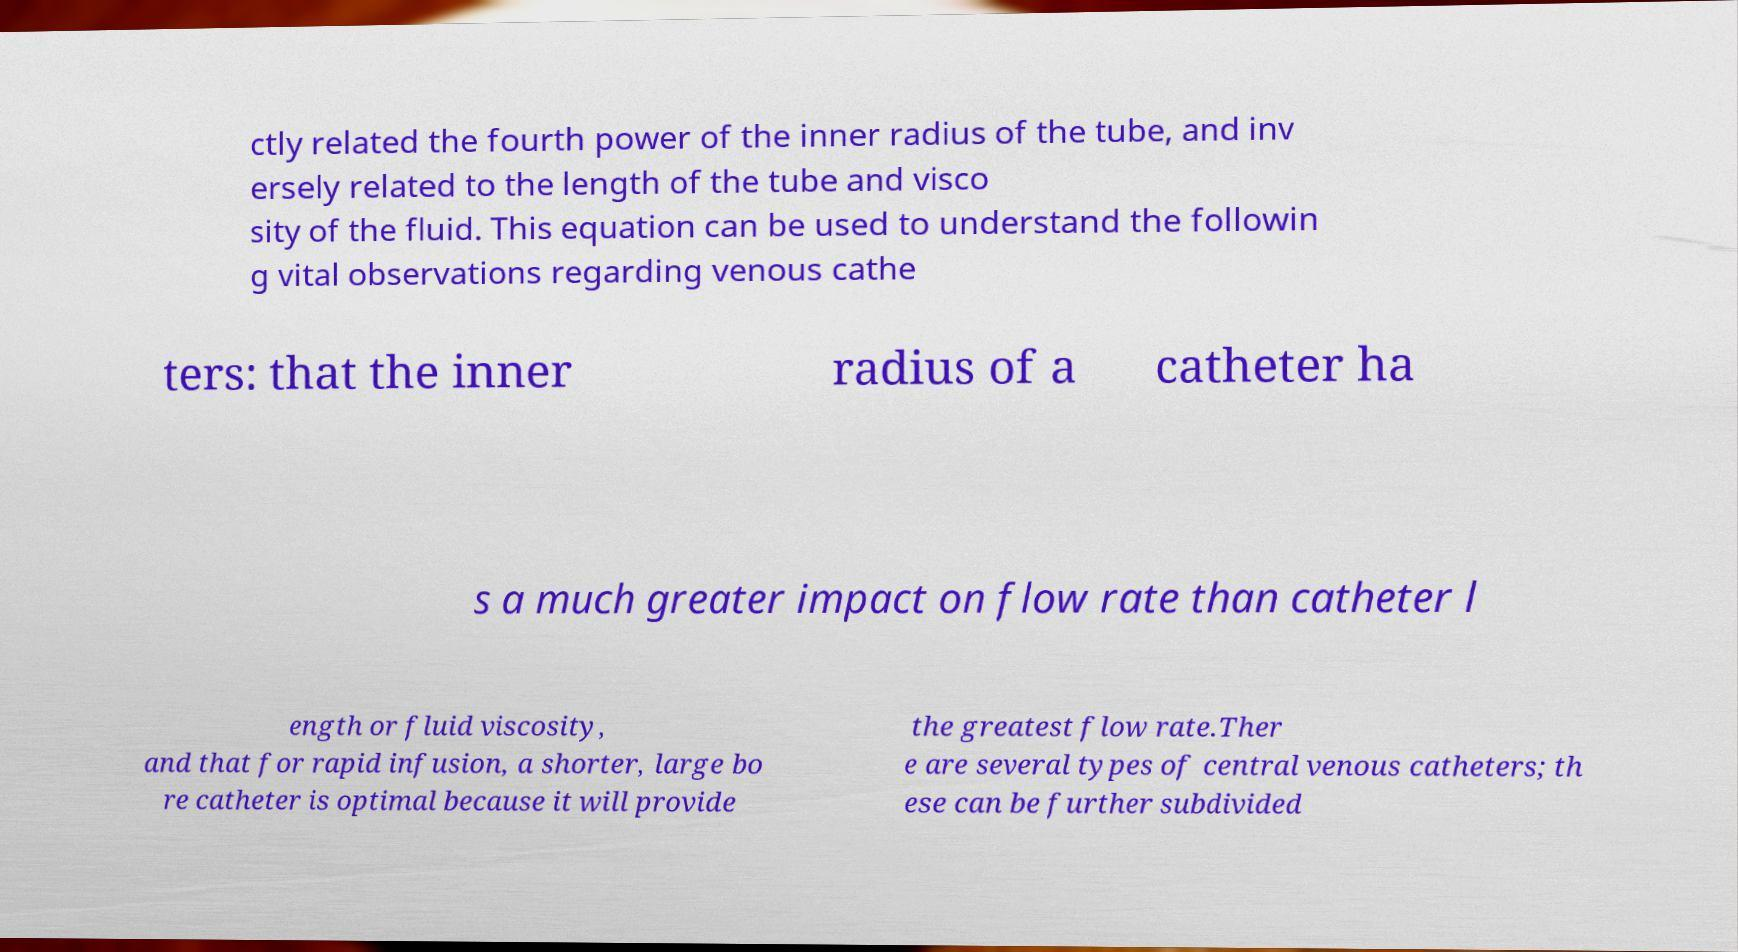For documentation purposes, I need the text within this image transcribed. Could you provide that? ctly related the fourth power of the inner radius of the tube, and inv ersely related to the length of the tube and visco sity of the fluid. This equation can be used to understand the followin g vital observations regarding venous cathe ters: that the inner radius of a catheter ha s a much greater impact on flow rate than catheter l ength or fluid viscosity, and that for rapid infusion, a shorter, large bo re catheter is optimal because it will provide the greatest flow rate.Ther e are several types of central venous catheters; th ese can be further subdivided 